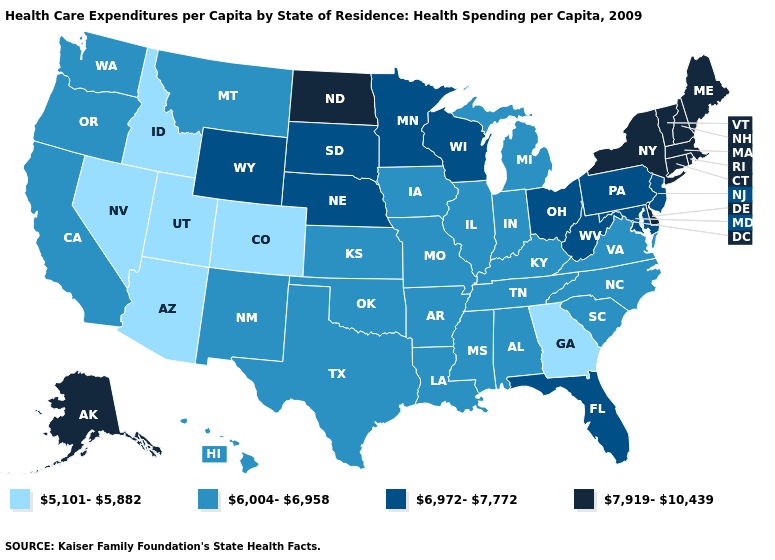Among the states that border Utah , does Nevada have the highest value?
Short answer required. No. Name the states that have a value in the range 5,101-5,882?
Keep it brief. Arizona, Colorado, Georgia, Idaho, Nevada, Utah. Does Arizona have the highest value in the West?
Keep it brief. No. Among the states that border Kentucky , does West Virginia have the lowest value?
Be succinct. No. Does Tennessee have a lower value than Kansas?
Write a very short answer. No. Among the states that border California , does Oregon have the lowest value?
Answer briefly. No. Among the states that border Kentucky , does Ohio have the lowest value?
Write a very short answer. No. What is the lowest value in the USA?
Quick response, please. 5,101-5,882. Name the states that have a value in the range 7,919-10,439?
Quick response, please. Alaska, Connecticut, Delaware, Maine, Massachusetts, New Hampshire, New York, North Dakota, Rhode Island, Vermont. What is the value of Texas?
Quick response, please. 6,004-6,958. Which states have the lowest value in the USA?
Be succinct. Arizona, Colorado, Georgia, Idaho, Nevada, Utah. Name the states that have a value in the range 6,972-7,772?
Short answer required. Florida, Maryland, Minnesota, Nebraska, New Jersey, Ohio, Pennsylvania, South Dakota, West Virginia, Wisconsin, Wyoming. Which states hav the highest value in the South?
Concise answer only. Delaware. Name the states that have a value in the range 6,972-7,772?
Answer briefly. Florida, Maryland, Minnesota, Nebraska, New Jersey, Ohio, Pennsylvania, South Dakota, West Virginia, Wisconsin, Wyoming. Which states have the lowest value in the USA?
Write a very short answer. Arizona, Colorado, Georgia, Idaho, Nevada, Utah. 